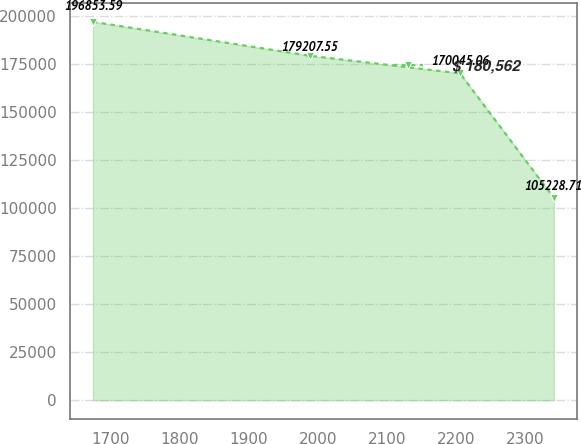Convert chart to OTSL. <chart><loc_0><loc_0><loc_500><loc_500><line_chart><ecel><fcel>$ 180,562<nl><fcel>1674.12<fcel>196854<nl><fcel>1987.82<fcel>179208<nl><fcel>2205.77<fcel>170045<nl><fcel>2341.64<fcel>105229<nl></chart> 